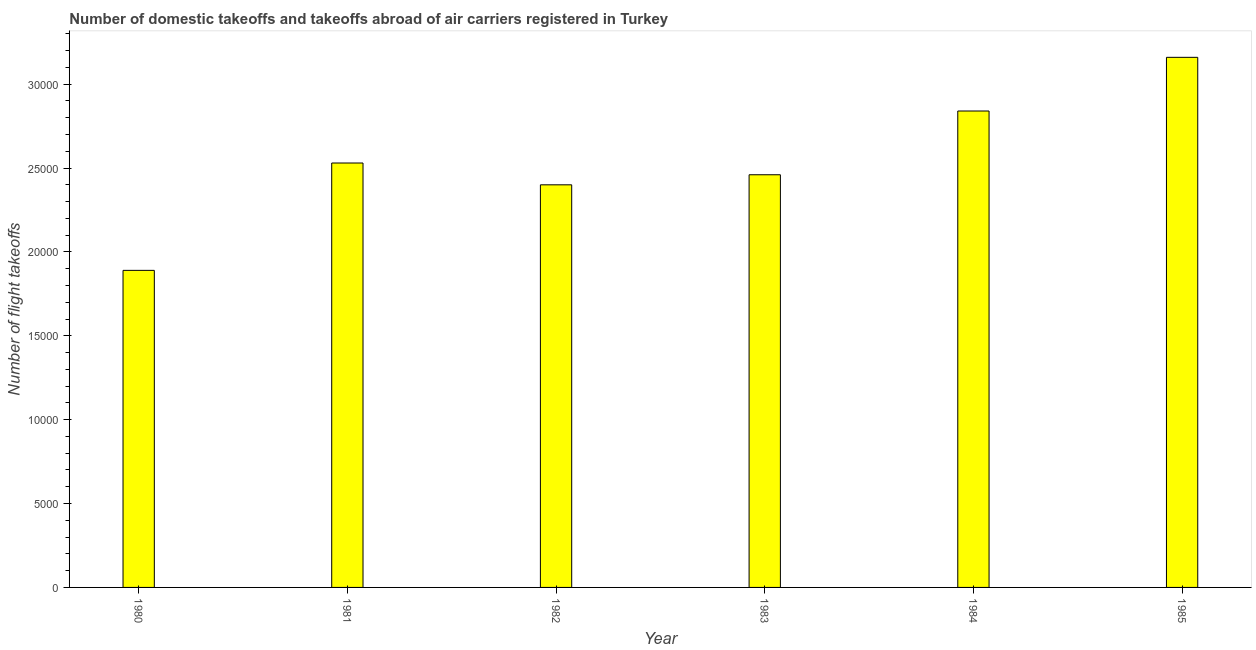What is the title of the graph?
Keep it short and to the point. Number of domestic takeoffs and takeoffs abroad of air carriers registered in Turkey. What is the label or title of the X-axis?
Offer a terse response. Year. What is the label or title of the Y-axis?
Provide a succinct answer. Number of flight takeoffs. What is the number of flight takeoffs in 1982?
Your answer should be very brief. 2.40e+04. Across all years, what is the maximum number of flight takeoffs?
Your answer should be very brief. 3.16e+04. Across all years, what is the minimum number of flight takeoffs?
Your answer should be compact. 1.89e+04. In which year was the number of flight takeoffs maximum?
Your response must be concise. 1985. In which year was the number of flight takeoffs minimum?
Your answer should be very brief. 1980. What is the sum of the number of flight takeoffs?
Offer a terse response. 1.53e+05. What is the difference between the number of flight takeoffs in 1982 and 1983?
Ensure brevity in your answer.  -600. What is the average number of flight takeoffs per year?
Your answer should be very brief. 2.55e+04. What is the median number of flight takeoffs?
Provide a succinct answer. 2.50e+04. In how many years, is the number of flight takeoffs greater than 17000 ?
Offer a terse response. 6. Do a majority of the years between 1983 and 1981 (inclusive) have number of flight takeoffs greater than 11000 ?
Keep it short and to the point. Yes. What is the ratio of the number of flight takeoffs in 1980 to that in 1981?
Ensure brevity in your answer.  0.75. Is the number of flight takeoffs in 1982 less than that in 1985?
Your response must be concise. Yes. What is the difference between the highest and the second highest number of flight takeoffs?
Keep it short and to the point. 3200. Is the sum of the number of flight takeoffs in 1980 and 1982 greater than the maximum number of flight takeoffs across all years?
Your answer should be compact. Yes. What is the difference between the highest and the lowest number of flight takeoffs?
Your answer should be very brief. 1.27e+04. How many bars are there?
Your answer should be very brief. 6. What is the Number of flight takeoffs of 1980?
Make the answer very short. 1.89e+04. What is the Number of flight takeoffs in 1981?
Make the answer very short. 2.53e+04. What is the Number of flight takeoffs in 1982?
Make the answer very short. 2.40e+04. What is the Number of flight takeoffs in 1983?
Your answer should be compact. 2.46e+04. What is the Number of flight takeoffs in 1984?
Keep it short and to the point. 2.84e+04. What is the Number of flight takeoffs of 1985?
Ensure brevity in your answer.  3.16e+04. What is the difference between the Number of flight takeoffs in 1980 and 1981?
Make the answer very short. -6400. What is the difference between the Number of flight takeoffs in 1980 and 1982?
Your answer should be compact. -5100. What is the difference between the Number of flight takeoffs in 1980 and 1983?
Give a very brief answer. -5700. What is the difference between the Number of flight takeoffs in 1980 and 1984?
Your answer should be very brief. -9500. What is the difference between the Number of flight takeoffs in 1980 and 1985?
Ensure brevity in your answer.  -1.27e+04. What is the difference between the Number of flight takeoffs in 1981 and 1982?
Offer a terse response. 1300. What is the difference between the Number of flight takeoffs in 1981 and 1983?
Your answer should be compact. 700. What is the difference between the Number of flight takeoffs in 1981 and 1984?
Keep it short and to the point. -3100. What is the difference between the Number of flight takeoffs in 1981 and 1985?
Make the answer very short. -6300. What is the difference between the Number of flight takeoffs in 1982 and 1983?
Make the answer very short. -600. What is the difference between the Number of flight takeoffs in 1982 and 1984?
Keep it short and to the point. -4400. What is the difference between the Number of flight takeoffs in 1982 and 1985?
Offer a very short reply. -7600. What is the difference between the Number of flight takeoffs in 1983 and 1984?
Your response must be concise. -3800. What is the difference between the Number of flight takeoffs in 1983 and 1985?
Ensure brevity in your answer.  -7000. What is the difference between the Number of flight takeoffs in 1984 and 1985?
Provide a short and direct response. -3200. What is the ratio of the Number of flight takeoffs in 1980 to that in 1981?
Offer a terse response. 0.75. What is the ratio of the Number of flight takeoffs in 1980 to that in 1982?
Offer a very short reply. 0.79. What is the ratio of the Number of flight takeoffs in 1980 to that in 1983?
Provide a succinct answer. 0.77. What is the ratio of the Number of flight takeoffs in 1980 to that in 1984?
Offer a very short reply. 0.67. What is the ratio of the Number of flight takeoffs in 1980 to that in 1985?
Your answer should be very brief. 0.6. What is the ratio of the Number of flight takeoffs in 1981 to that in 1982?
Offer a terse response. 1.05. What is the ratio of the Number of flight takeoffs in 1981 to that in 1983?
Keep it short and to the point. 1.03. What is the ratio of the Number of flight takeoffs in 1981 to that in 1984?
Give a very brief answer. 0.89. What is the ratio of the Number of flight takeoffs in 1981 to that in 1985?
Your answer should be compact. 0.8. What is the ratio of the Number of flight takeoffs in 1982 to that in 1983?
Offer a terse response. 0.98. What is the ratio of the Number of flight takeoffs in 1982 to that in 1984?
Offer a terse response. 0.84. What is the ratio of the Number of flight takeoffs in 1982 to that in 1985?
Provide a short and direct response. 0.76. What is the ratio of the Number of flight takeoffs in 1983 to that in 1984?
Give a very brief answer. 0.87. What is the ratio of the Number of flight takeoffs in 1983 to that in 1985?
Offer a terse response. 0.78. What is the ratio of the Number of flight takeoffs in 1984 to that in 1985?
Your response must be concise. 0.9. 